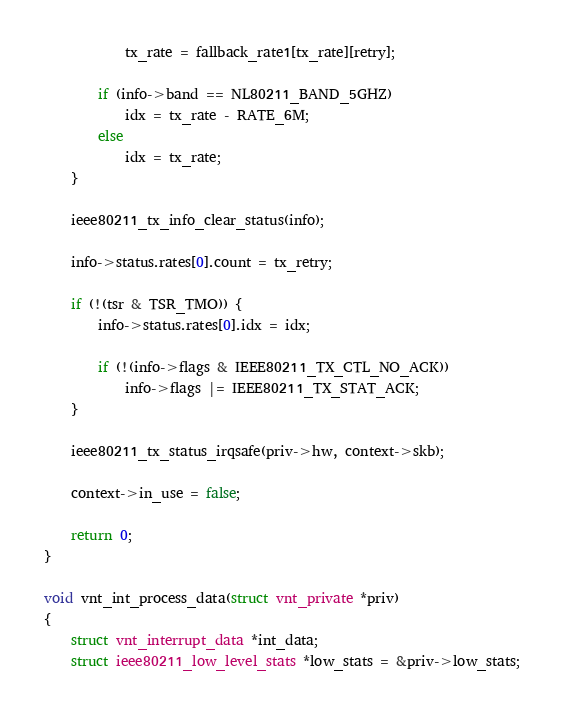Convert code to text. <code><loc_0><loc_0><loc_500><loc_500><_C_>			tx_rate = fallback_rate1[tx_rate][retry];

		if (info->band == NL80211_BAND_5GHZ)
			idx = tx_rate - RATE_6M;
		else
			idx = tx_rate;
	}

	ieee80211_tx_info_clear_status(info);

	info->status.rates[0].count = tx_retry;

	if (!(tsr & TSR_TMO)) {
		info->status.rates[0].idx = idx;

		if (!(info->flags & IEEE80211_TX_CTL_NO_ACK))
			info->flags |= IEEE80211_TX_STAT_ACK;
	}

	ieee80211_tx_status_irqsafe(priv->hw, context->skb);

	context->in_use = false;

	return 0;
}

void vnt_int_process_data(struct vnt_private *priv)
{
	struct vnt_interrupt_data *int_data;
	struct ieee80211_low_level_stats *low_stats = &priv->low_stats;
</code> 